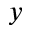<formula> <loc_0><loc_0><loc_500><loc_500>_ { y }</formula> 